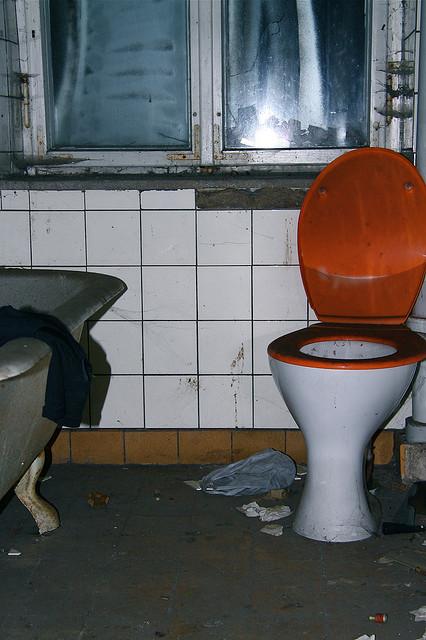Is the wall tiled?
Concise answer only. Yes. Is there a tub in this room?
Be succinct. Yes. Is this room clean?
Give a very brief answer. No. 